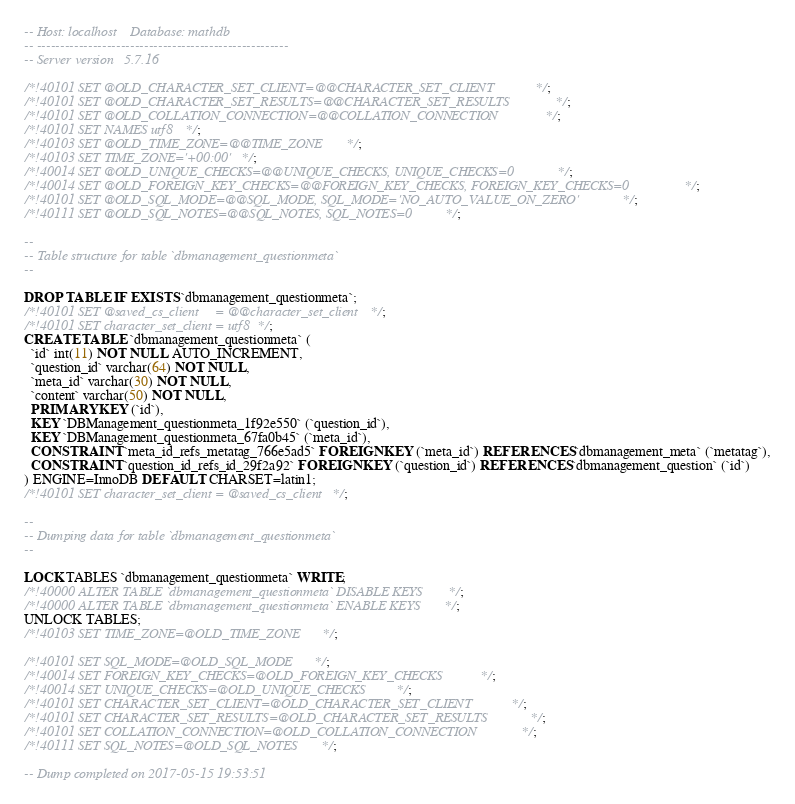Convert code to text. <code><loc_0><loc_0><loc_500><loc_500><_SQL_>-- Host: localhost    Database: mathdb
-- ------------------------------------------------------
-- Server version	5.7.16

/*!40101 SET @OLD_CHARACTER_SET_CLIENT=@@CHARACTER_SET_CLIENT */;
/*!40101 SET @OLD_CHARACTER_SET_RESULTS=@@CHARACTER_SET_RESULTS */;
/*!40101 SET @OLD_COLLATION_CONNECTION=@@COLLATION_CONNECTION */;
/*!40101 SET NAMES utf8 */;
/*!40103 SET @OLD_TIME_ZONE=@@TIME_ZONE */;
/*!40103 SET TIME_ZONE='+00:00' */;
/*!40014 SET @OLD_UNIQUE_CHECKS=@@UNIQUE_CHECKS, UNIQUE_CHECKS=0 */;
/*!40014 SET @OLD_FOREIGN_KEY_CHECKS=@@FOREIGN_KEY_CHECKS, FOREIGN_KEY_CHECKS=0 */;
/*!40101 SET @OLD_SQL_MODE=@@SQL_MODE, SQL_MODE='NO_AUTO_VALUE_ON_ZERO' */;
/*!40111 SET @OLD_SQL_NOTES=@@SQL_NOTES, SQL_NOTES=0 */;

--
-- Table structure for table `dbmanagement_questionmeta`
--

DROP TABLE IF EXISTS `dbmanagement_questionmeta`;
/*!40101 SET @saved_cs_client     = @@character_set_client */;
/*!40101 SET character_set_client = utf8 */;
CREATE TABLE `dbmanagement_questionmeta` (
  `id` int(11) NOT NULL AUTO_INCREMENT,
  `question_id` varchar(64) NOT NULL,
  `meta_id` varchar(30) NOT NULL,
  `content` varchar(50) NOT NULL,
  PRIMARY KEY (`id`),
  KEY `DBManagement_questionmeta_1f92e550` (`question_id`),
  KEY `DBManagement_questionmeta_67fa0b45` (`meta_id`),
  CONSTRAINT `meta_id_refs_metatag_766e5ad5` FOREIGN KEY (`meta_id`) REFERENCES `dbmanagement_meta` (`metatag`),
  CONSTRAINT `question_id_refs_id_29f2a92` FOREIGN KEY (`question_id`) REFERENCES `dbmanagement_question` (`id`)
) ENGINE=InnoDB DEFAULT CHARSET=latin1;
/*!40101 SET character_set_client = @saved_cs_client */;

--
-- Dumping data for table `dbmanagement_questionmeta`
--

LOCK TABLES `dbmanagement_questionmeta` WRITE;
/*!40000 ALTER TABLE `dbmanagement_questionmeta` DISABLE KEYS */;
/*!40000 ALTER TABLE `dbmanagement_questionmeta` ENABLE KEYS */;
UNLOCK TABLES;
/*!40103 SET TIME_ZONE=@OLD_TIME_ZONE */;

/*!40101 SET SQL_MODE=@OLD_SQL_MODE */;
/*!40014 SET FOREIGN_KEY_CHECKS=@OLD_FOREIGN_KEY_CHECKS */;
/*!40014 SET UNIQUE_CHECKS=@OLD_UNIQUE_CHECKS */;
/*!40101 SET CHARACTER_SET_CLIENT=@OLD_CHARACTER_SET_CLIENT */;
/*!40101 SET CHARACTER_SET_RESULTS=@OLD_CHARACTER_SET_RESULTS */;
/*!40101 SET COLLATION_CONNECTION=@OLD_COLLATION_CONNECTION */;
/*!40111 SET SQL_NOTES=@OLD_SQL_NOTES */;

-- Dump completed on 2017-05-15 19:53:51
</code> 